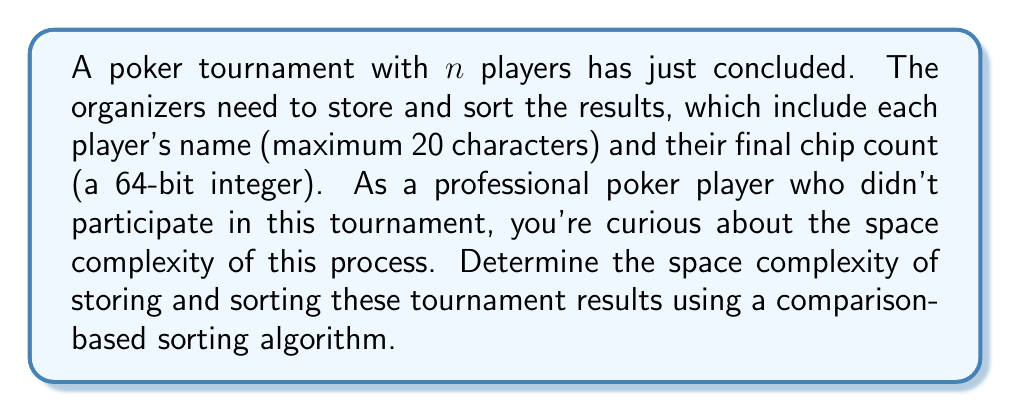Help me with this question. Let's break this down step-by-step:

1. Storage requirements:
   - Each player's name: 20 characters * 1 byte per character = 20 bytes
   - Each player's chip count: 64 bits = 8 bytes
   - Total per player: 20 + 8 = 28 bytes

2. For $n$ players, the total storage required is:
   $$ 28n \text{ bytes} $$

3. For sorting, we need to consider the space complexity of comparison-based sorting algorithms. The most efficient comparison-based sorting algorithms (like Merge Sort or Heap Sort) have a space complexity of $O(n)$ in addition to the input array.

4. The space complexity for sorting is therefore:
   $$ O(n) + 28n \text{ bytes} $$

5. In Big O notation, we drop constant factors and lower-order terms. The dominant term here is $O(n)$.

6. Therefore, the overall space complexity for both storing and sorting is $O(n)$.

It's worth noting that while the actual space used is $28n + O(n)$ bytes, in computational complexity theory, we focus on the asymptotic behavior, which is captured by the $O(n)$ notation.
Answer: $O(n)$ 